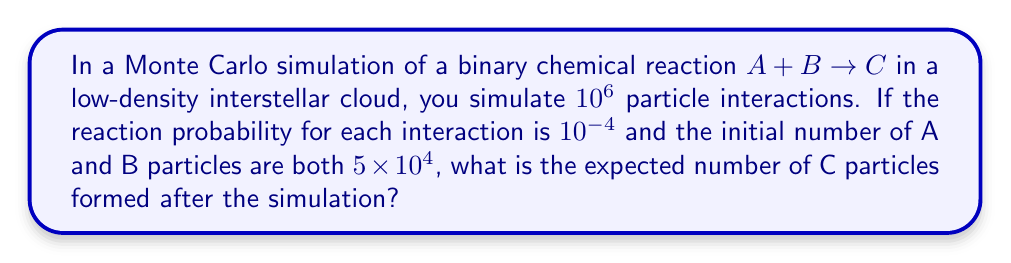Can you solve this math problem? To solve this problem, we'll follow these steps:

1) In a Monte Carlo simulation, each interaction is treated as an independent event. The probability of a reaction occurring in each interaction is given as $10^{-4}$.

2) The total number of interactions simulated is $10^6$.

3) To calculate the expected number of reactions (and thus C particles formed), we multiply the number of interactions by the probability of reaction:

   Expected reactions = $10^6 \times 10^{-4} = 100$

4) However, we need to consider if there are enough A and B particles for 100 reactions to occur. Each reaction consumes one A particle and one B particle.

5) The initial number of both A and B particles is $5 \times 10^4$. This is the limiting factor, as there are only enough particles for $5 \times 10^4$ reactions to occur.

6) Since $5 \times 10^4 > 100$, there are enough particles for all expected reactions to occur.

Therefore, the expected number of C particles formed is 100.
Answer: 100 